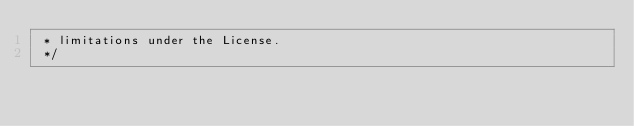<code> <loc_0><loc_0><loc_500><loc_500><_SQL_> * limitations under the License.
 */

</code> 